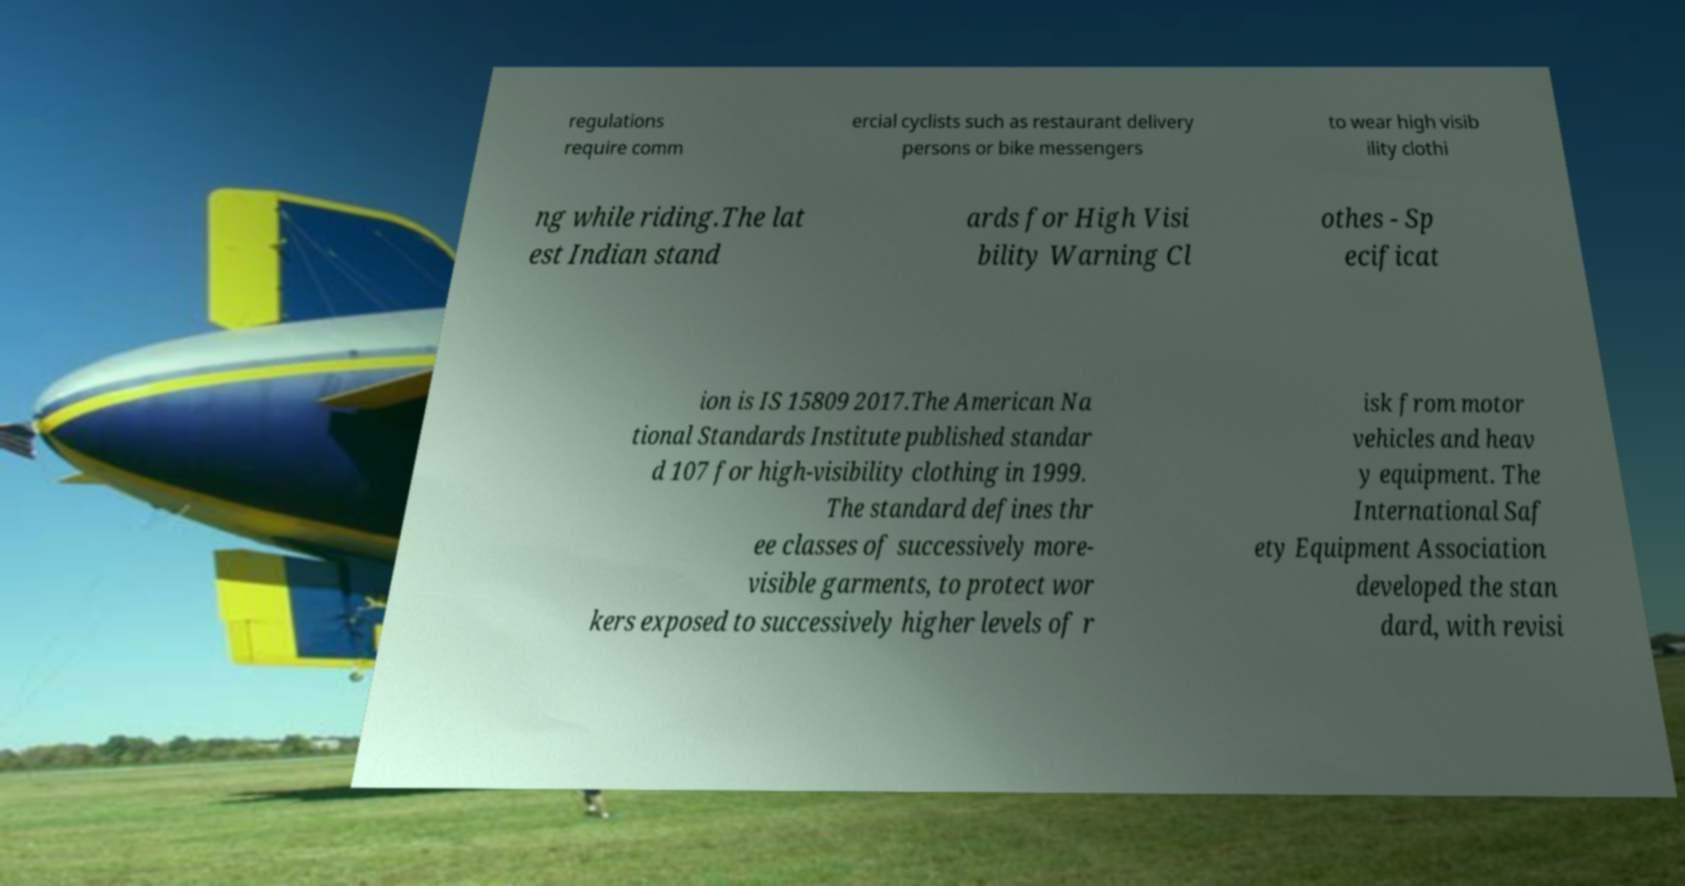For documentation purposes, I need the text within this image transcribed. Could you provide that? regulations require comm ercial cyclists such as restaurant delivery persons or bike messengers to wear high visib ility clothi ng while riding.The lat est Indian stand ards for High Visi bility Warning Cl othes - Sp ecificat ion is IS 15809 2017.The American Na tional Standards Institute published standar d 107 for high-visibility clothing in 1999. The standard defines thr ee classes of successively more- visible garments, to protect wor kers exposed to successively higher levels of r isk from motor vehicles and heav y equipment. The International Saf ety Equipment Association developed the stan dard, with revisi 